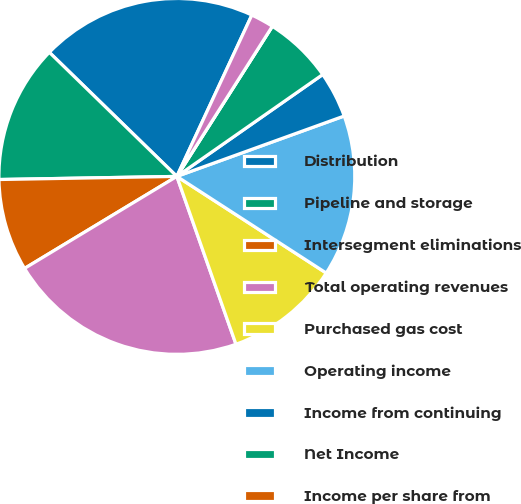Convert chart to OTSL. <chart><loc_0><loc_0><loc_500><loc_500><pie_chart><fcel>Distribution<fcel>Pipeline and storage<fcel>Intersegment eliminations<fcel>Total operating revenues<fcel>Purchased gas cost<fcel>Operating income<fcel>Income from continuing<fcel>Net Income<fcel>Income per share from<fcel>Net income per share - basic<nl><fcel>19.64%<fcel>12.56%<fcel>8.37%<fcel>21.74%<fcel>10.47%<fcel>14.65%<fcel>4.19%<fcel>6.28%<fcel>0.0%<fcel>2.09%<nl></chart> 